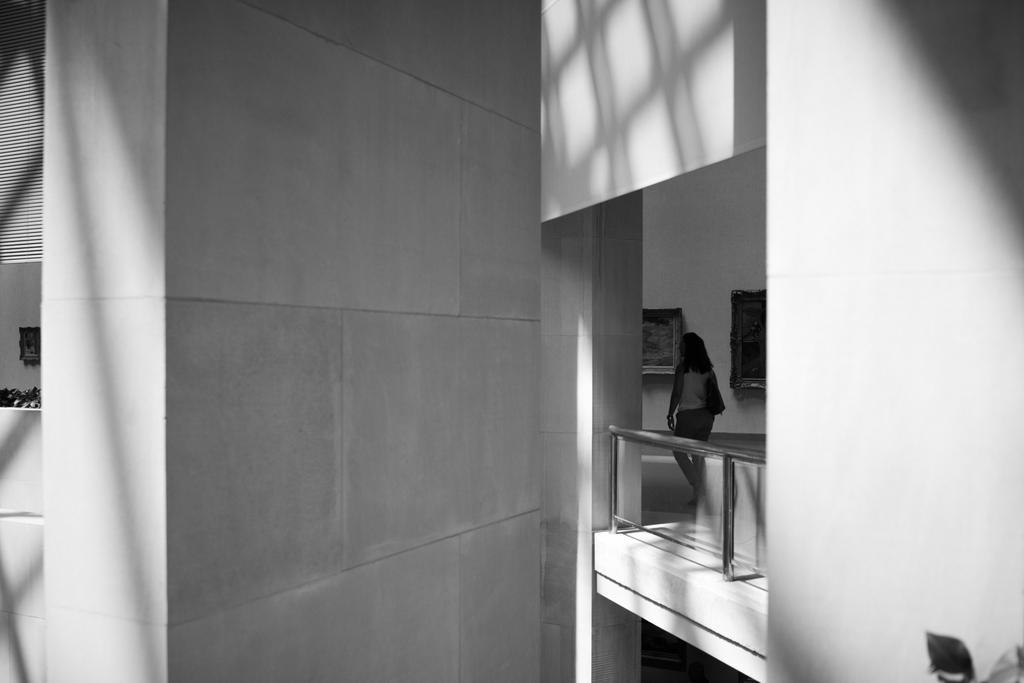Describe this image in one or two sentences. In this picture we can see the walls, frames, railing, leaves and a woman carrying a bag. 